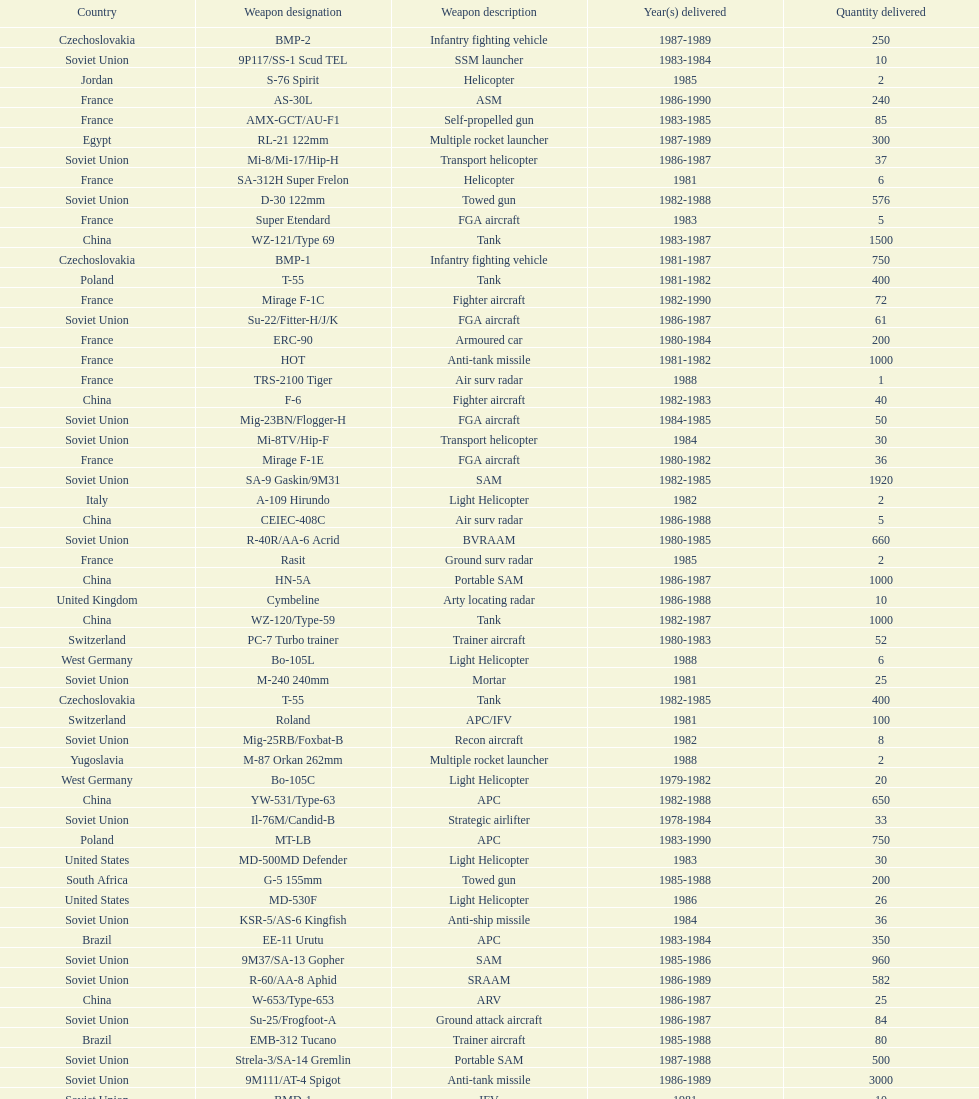According to this list, how many countries sold weapons to iraq? 21. 